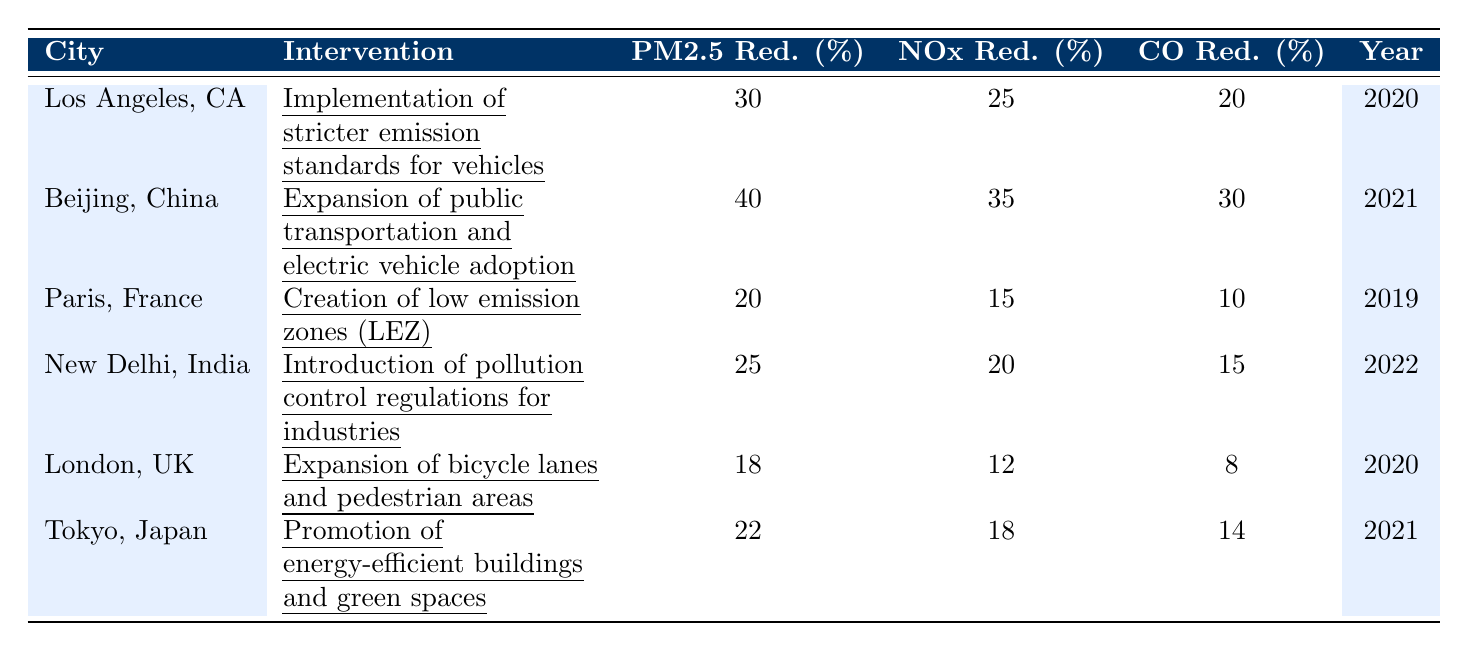What was the PM2.5 reduction percentage for Beijing, China? According to the table, the PM2.5 reduction percentage listed for Beijing is 40%.
Answer: 40% Which city had the highest reduction in CO emissions? By examining the CO reduction percentages, Beijing has a 30% reduction, which is higher than any other city listed.
Answer: Beijing, China Did New Delhi, India implement the same interventions as Paris, France? The table shows that New Delhi introduced pollution control regulations for industries, while Paris created low emission zones; thus, they did not implement the same interventions.
Answer: No Calculate the average NOx reduction percentage across all cities listed. The NOx reductions are 25, 35, 15, 20, 12, and 18. Summing these gives 125, and there are 6 cities, so the average is 125/6 = approximately 20.83%.
Answer: 20.83% Which city had the lowest PM2.5 reduction, and what was that percentage? Looking at the PM2.5 reductions, London, UK had the lowest at 18%.
Answer: London, UK; 18% Is there a correlation between the year of intervention and the amount of CO reduction? Analyzing the table, lower CO reductions (like 8% for London in 2020) do not show a consistent pattern with later interventions having higher reductions, as seen with Beijing in 2021 showing a 30% reduction. Thus, no clear correlation exists.
Answer: No What was the difference in NOx reduction between Los Angeles, CA and Tokyo, Japan? The NOx reduction for Los Angeles is 25%, while for Tokyo, it is 18%. The difference is 25% - 18% = 7%.
Answer: 7% Which city had a PM2.5 reduction greater than 20%, and what interventions did they use? The cities with PM2.5 reductions above 20% are Beijing (40%, expansion of public transportation and electric vehicle adoption) and Los Angeles (30%, implementation of stricter emission standards for vehicles).
Answer: Beijing and Los Angeles Calculate the sum of CO reductions for all cities. The CO reductions are 20, 30, 10, 15, 8, and 14. Adding these together gives 20 + 30 + 10 + 15 + 8 + 14 = 97%.
Answer: 97% In which year did Paris implement its air quality intervention? The table indicates that Paris implemented its low emission zones (LEZ) in 2019.
Answer: 2019 